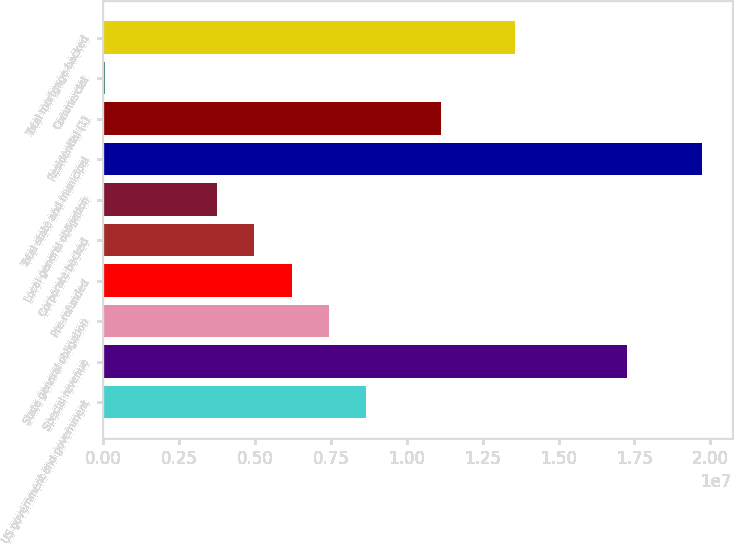Convert chart to OTSL. <chart><loc_0><loc_0><loc_500><loc_500><bar_chart><fcel>US government and government<fcel>Special revenue<fcel>State general obligation<fcel>Pre-refunded<fcel>Corporate backed<fcel>Local general obligation<fcel>Total state and municipal<fcel>Residential (1)<fcel>Commercial<fcel>Total mortgage-backed<nl><fcel>8.66341e+06<fcel>1.72611e+07<fcel>7.43516e+06<fcel>6.20692e+06<fcel>4.97868e+06<fcel>3.75044e+06<fcel>1.97176e+07<fcel>1.11199e+07<fcel>65722<fcel>1.35764e+07<nl></chart> 